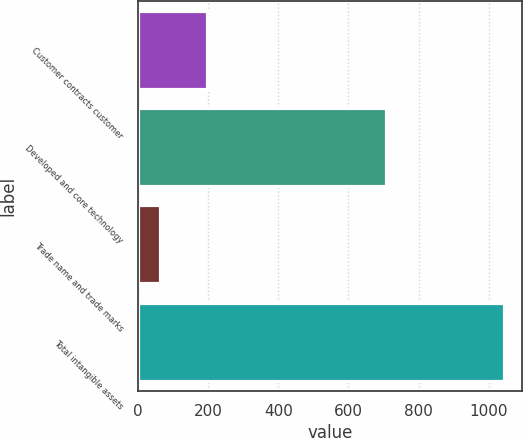Convert chart. <chart><loc_0><loc_0><loc_500><loc_500><bar_chart><fcel>Customer contracts customer<fcel>Developed and core technology<fcel>Trade name and trade marks<fcel>Total intangible assets<nl><fcel>197<fcel>706<fcel>64<fcel>1042<nl></chart> 